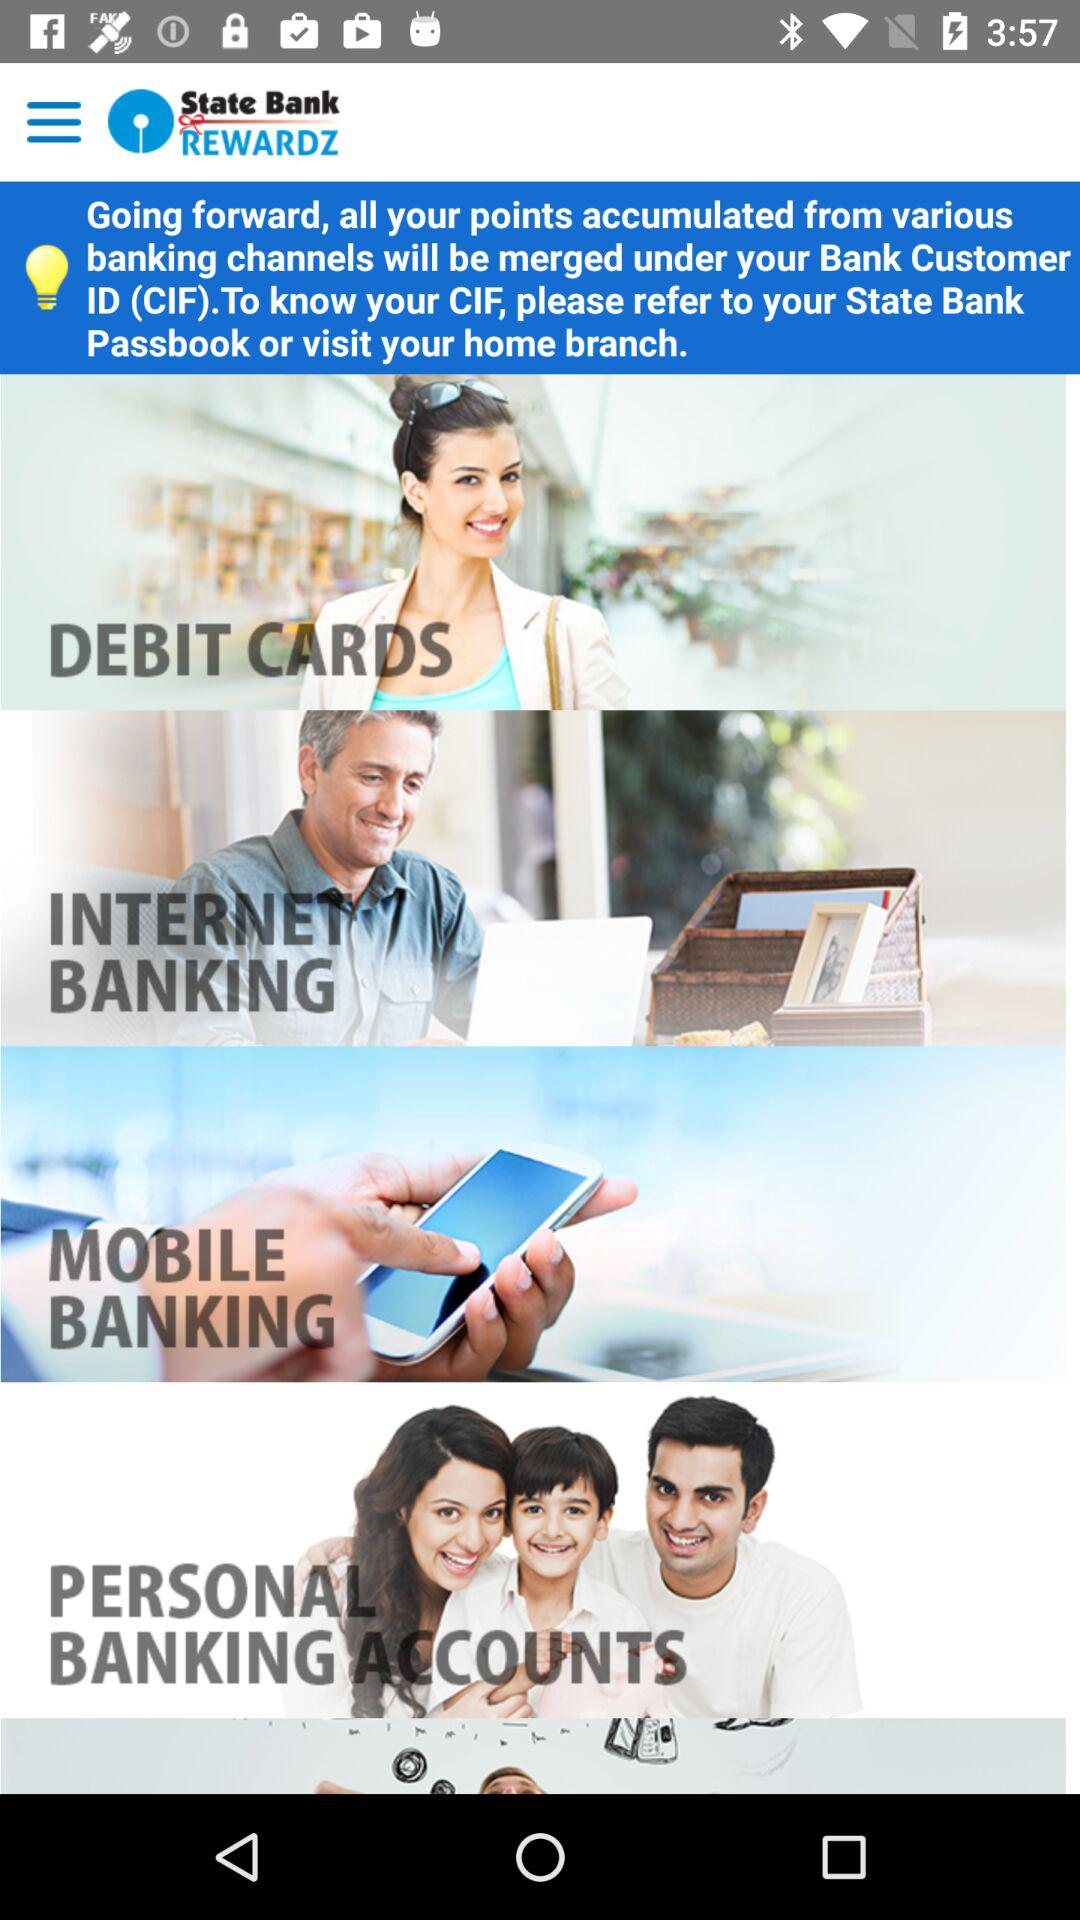What is the name of the application? The name of the application is "State Bank REWARDZ". 